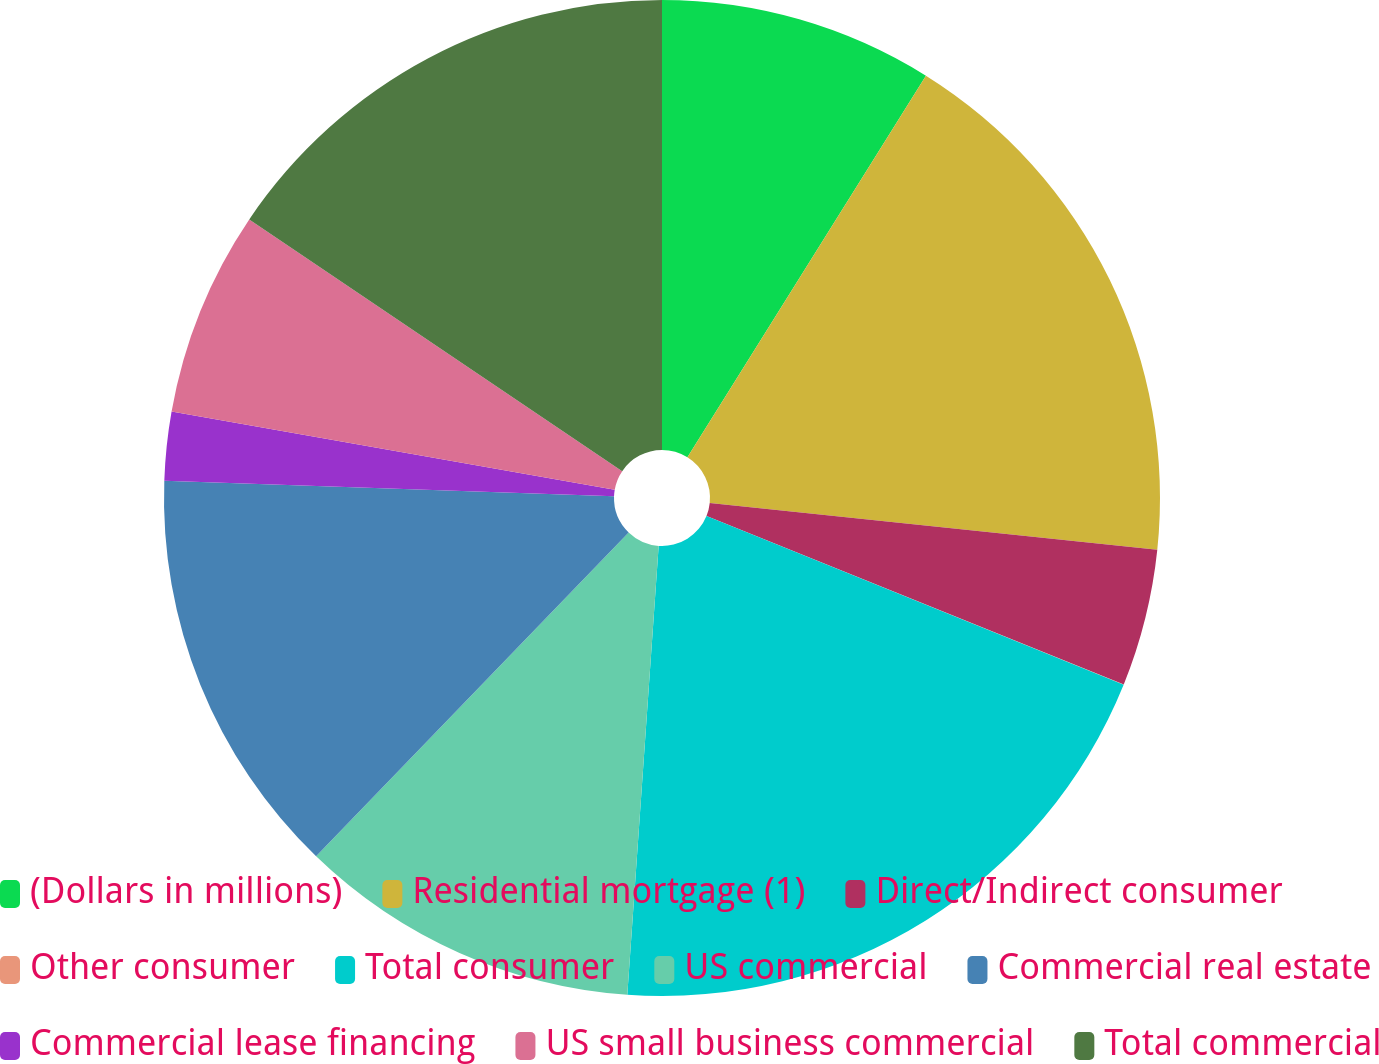<chart> <loc_0><loc_0><loc_500><loc_500><pie_chart><fcel>(Dollars in millions)<fcel>Residential mortgage (1)<fcel>Direct/Indirect consumer<fcel>Other consumer<fcel>Total consumer<fcel>US commercial<fcel>Commercial real estate<fcel>Commercial lease financing<fcel>US small business commercial<fcel>Total commercial<nl><fcel>8.89%<fcel>17.77%<fcel>4.45%<fcel>0.01%<fcel>19.99%<fcel>11.11%<fcel>13.33%<fcel>2.23%<fcel>6.67%<fcel>15.55%<nl></chart> 